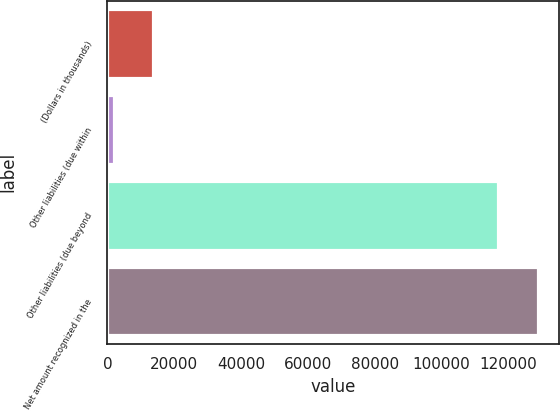Convert chart to OTSL. <chart><loc_0><loc_0><loc_500><loc_500><bar_chart><fcel>(Dollars in thousands)<fcel>Other liabilities (due within<fcel>Other liabilities (due beyond<fcel>Net amount recognized in the<nl><fcel>13575.7<fcel>1869<fcel>117067<fcel>128774<nl></chart> 